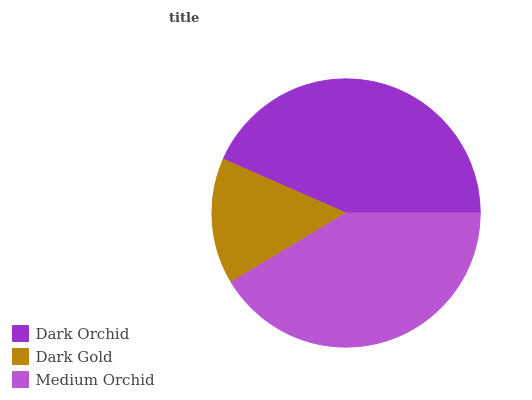Is Dark Gold the minimum?
Answer yes or no. Yes. Is Dark Orchid the maximum?
Answer yes or no. Yes. Is Medium Orchid the minimum?
Answer yes or no. No. Is Medium Orchid the maximum?
Answer yes or no. No. Is Medium Orchid greater than Dark Gold?
Answer yes or no. Yes. Is Dark Gold less than Medium Orchid?
Answer yes or no. Yes. Is Dark Gold greater than Medium Orchid?
Answer yes or no. No. Is Medium Orchid less than Dark Gold?
Answer yes or no. No. Is Medium Orchid the high median?
Answer yes or no. Yes. Is Medium Orchid the low median?
Answer yes or no. Yes. Is Dark Gold the high median?
Answer yes or no. No. Is Dark Orchid the low median?
Answer yes or no. No. 